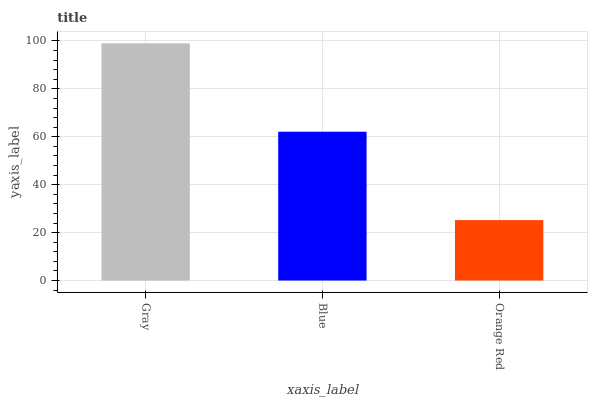Is Orange Red the minimum?
Answer yes or no. Yes. Is Gray the maximum?
Answer yes or no. Yes. Is Blue the minimum?
Answer yes or no. No. Is Blue the maximum?
Answer yes or no. No. Is Gray greater than Blue?
Answer yes or no. Yes. Is Blue less than Gray?
Answer yes or no. Yes. Is Blue greater than Gray?
Answer yes or no. No. Is Gray less than Blue?
Answer yes or no. No. Is Blue the high median?
Answer yes or no. Yes. Is Blue the low median?
Answer yes or no. Yes. Is Orange Red the high median?
Answer yes or no. No. Is Gray the low median?
Answer yes or no. No. 